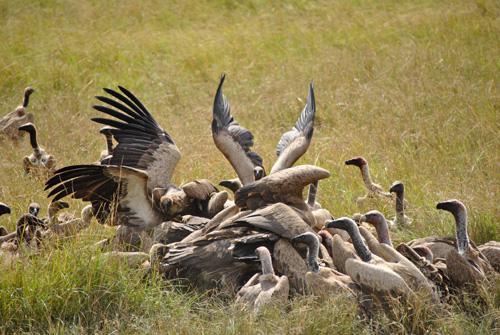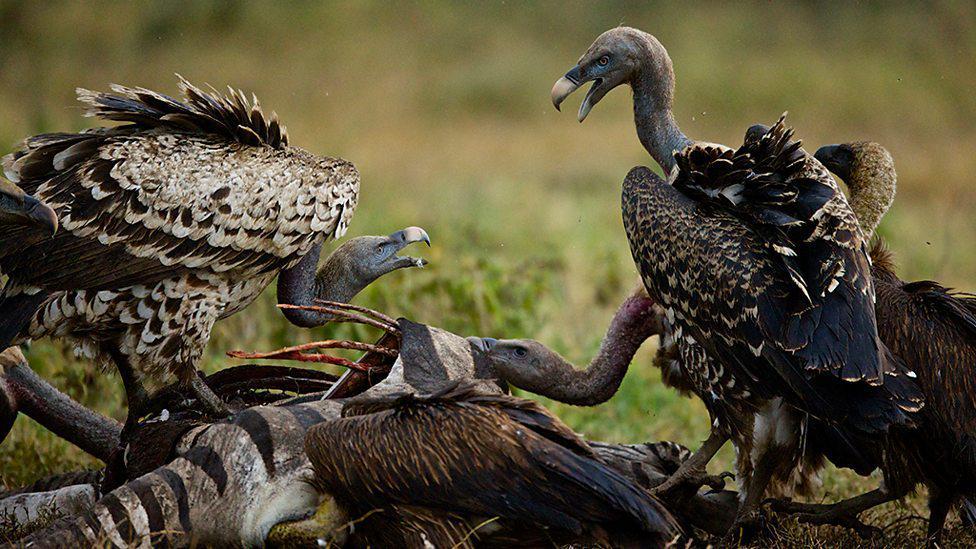The first image is the image on the left, the second image is the image on the right. Evaluate the accuracy of this statement regarding the images: "All vultures in one image are off the ground.". Is it true? Answer yes or no. No. The first image is the image on the left, the second image is the image on the right. Evaluate the accuracy of this statement regarding the images: "In 1 of the images, at least 1 bird is flying.". Is it true? Answer yes or no. No. 